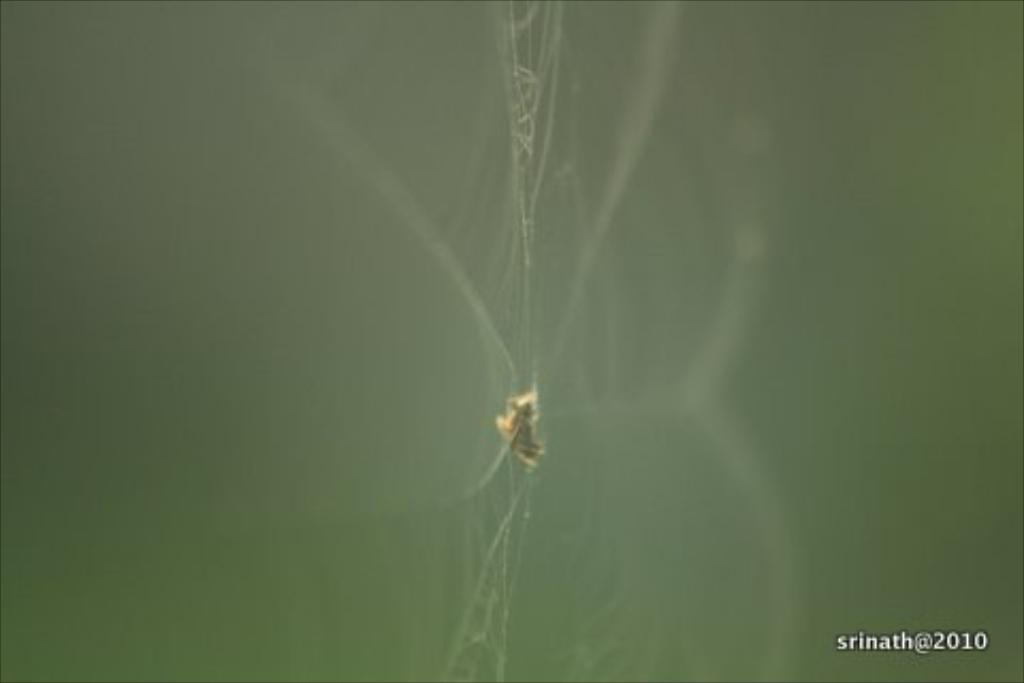What is the main subject in the center of the image? There is a spider web in the center of the image. Is there any text or marking in the image? Yes, there is a watermark in the bottom right corner of the image. How do the dolls react to the quicksand in the image? There are no dolls or quicksand present in the image. 